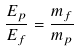<formula> <loc_0><loc_0><loc_500><loc_500>\frac { E _ { p } } { E _ { f } } = \frac { m _ { f } } { m _ { p } }</formula> 